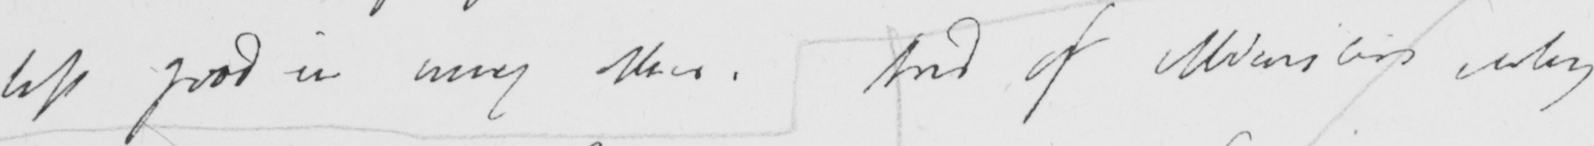Can you read and transcribe this handwriting? less good in many others . And if Ministers why 